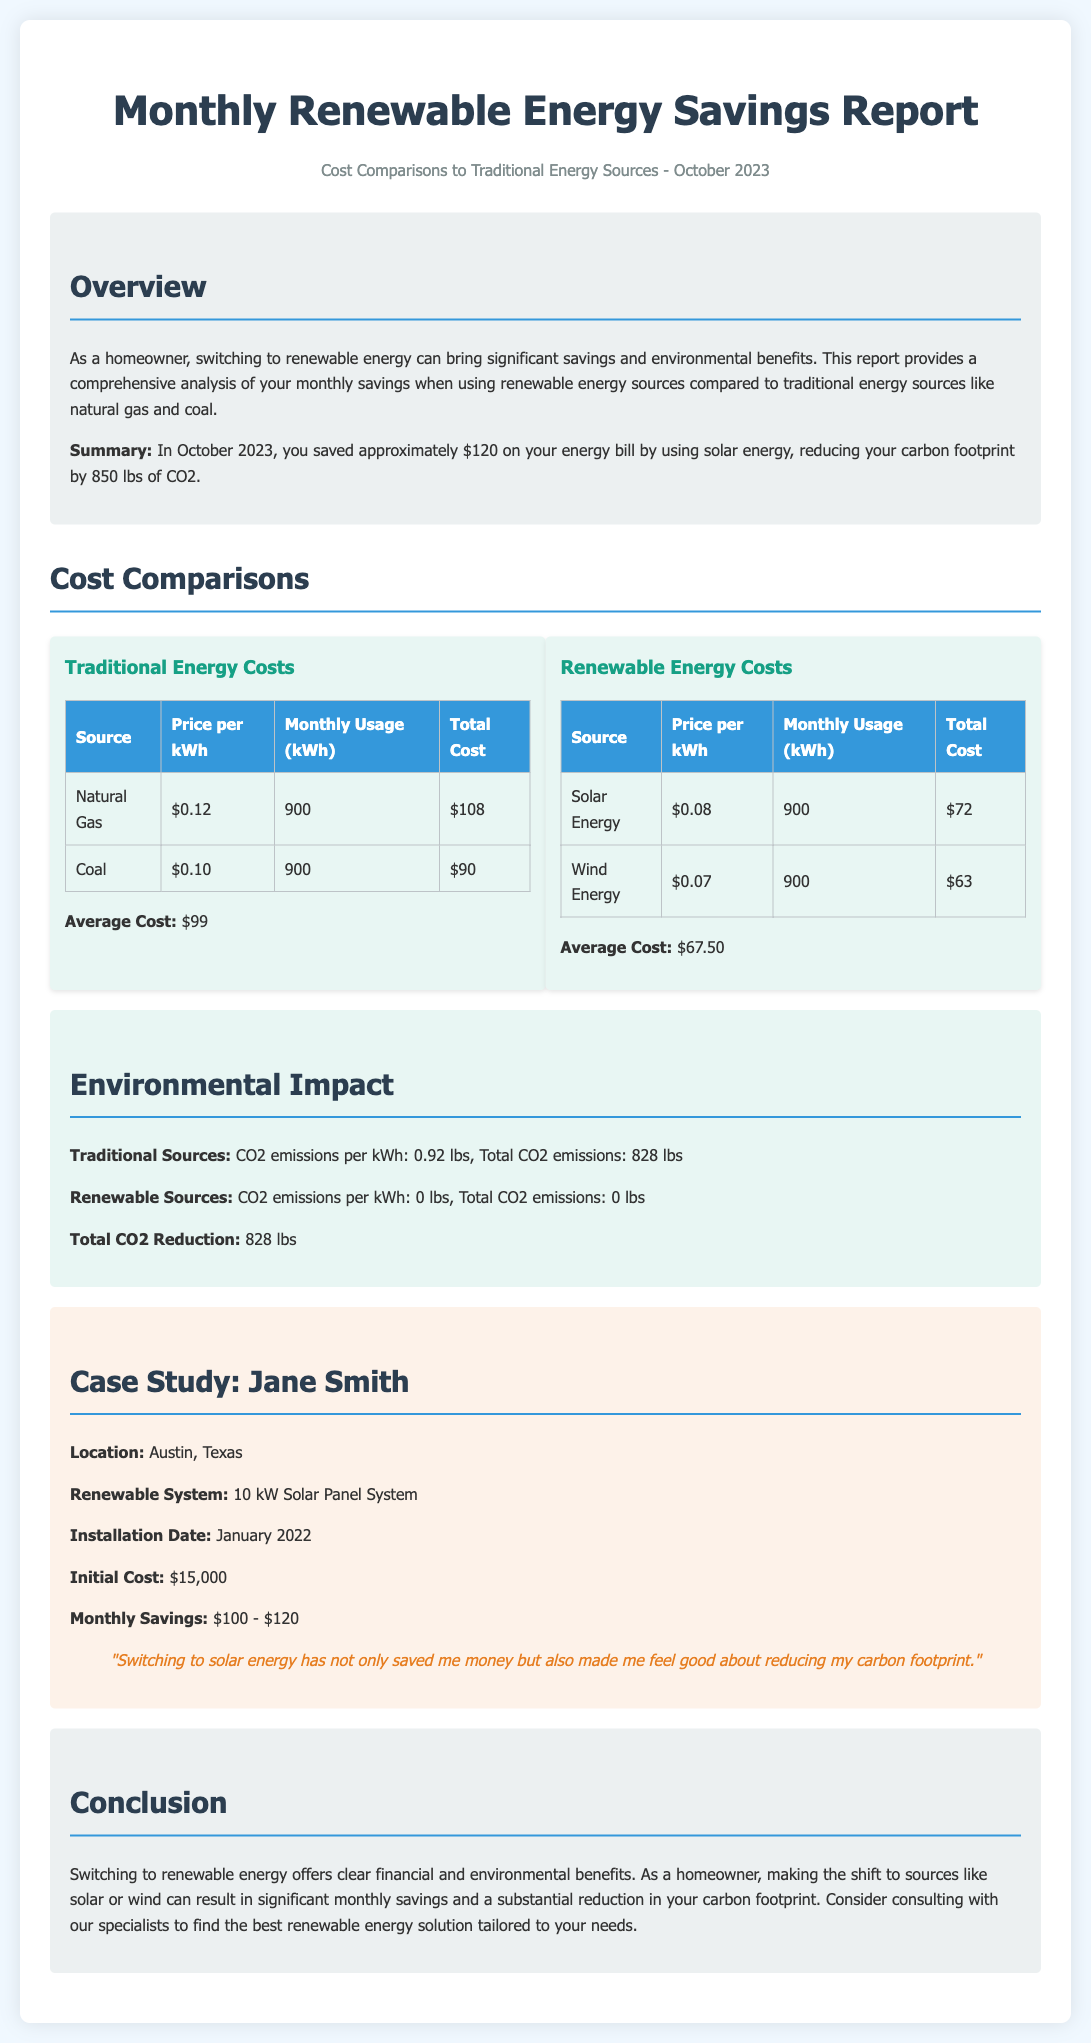What is the title of the report? The title of the report is presented at the top of the document.
Answer: Monthly Renewable Energy Savings Report What was the total savings reported for October 2023? The total savings is mentioned in the overview section of the document.
Answer: $120 What is the average cost of renewable energy? The average cost is calculated and listed under the renewable energy costs section.
Answer: $67.50 How much CO2 was reduced by switching to renewable energy? The reduction in CO2 is outlined in the environmental impact section of the document.
Answer: 828 lbs What is the initial cost of Jane Smith's solar panel system? The initial cost is specified in the case study section regarding Jane Smith.
Answer: $15,000 What is the price per kWh for solar energy? The price per kWh is listed in the renewable energy costs table.
Answer: $0.08 What type of renewable system did Jane Smith install? The document provides information on the type of renewable system in the case study.
Answer: 10 kW Solar Panel System What emissions do renewable sources produce per kWh? The emissions from renewable sources are mentioned in the environmental impact section.
Answer: 0 lbs What was the monthly savings range for Jane Smith? The range of monthly savings is stated in the case study associated with Jane Smith.
Answer: $100 - $120 